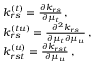<formula> <loc_0><loc_0><loc_500><loc_500>\begin{array} { r l } & { k _ { r s } ^ { ( t ) } = \frac { \partial k _ { r s } } { \partial \mu _ { t } } \, , } \\ & { k _ { r s } ^ { ( t u ) } = \frac { \partial ^ { 2 } k _ { r s } } { \partial \mu _ { t } \partial \mu _ { u } } \, , } \\ & { k _ { r s t } ^ { ( u ) } = \frac { \partial k _ { r s t } } { \partial \mu _ { u } } \, , } \end{array}</formula> 